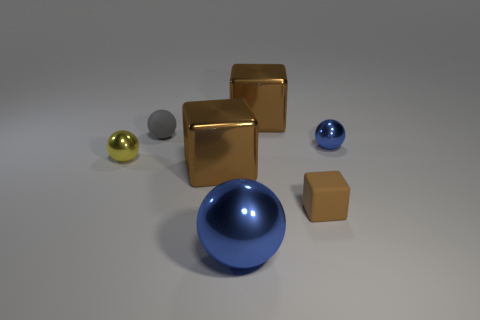Are there any other large balls of the same color as the rubber sphere?
Your answer should be very brief. No. How many objects are blue metallic spheres behind the tiny rubber block or large rubber cubes?
Make the answer very short. 1. What material is the small cube that is to the right of the big brown object in front of the yellow metal thing that is left of the small rubber block?
Make the answer very short. Rubber. How many cubes are gray rubber objects or shiny things?
Your answer should be very brief. 2. Is there anything else that has the same shape as the tiny yellow thing?
Offer a terse response. Yes. Is the number of brown rubber things that are behind the gray matte ball greater than the number of small gray matte spheres behind the big blue shiny sphere?
Your response must be concise. No. How many small yellow objects are to the right of the big brown metallic block in front of the tiny yellow shiny ball?
Your answer should be compact. 0. How many objects are either tiny objects or large blocks?
Offer a very short reply. 6. Is the gray object the same shape as the small blue thing?
Offer a very short reply. Yes. What is the small yellow sphere made of?
Offer a very short reply. Metal. 